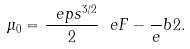Convert formula to latex. <formula><loc_0><loc_0><loc_500><loc_500>\mu _ { 0 } = \frac { \ e p s ^ { 3 / 2 } } 2 \ e F - \frac { \ } { e } b 2 .</formula> 